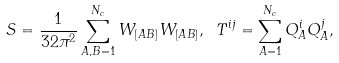Convert formula to latex. <formula><loc_0><loc_0><loc_500><loc_500>S = \frac { 1 } { 3 2 \pi ^ { 2 } } \sum _ { A , B = 1 } ^ { N _ { c } } W _ { [ A B ] } W _ { [ A B ] } , \ T ^ { i j } = \sum _ { A = 1 } ^ { N _ { c } } Q _ { A } ^ { i } Q _ { A } ^ { j } ,</formula> 